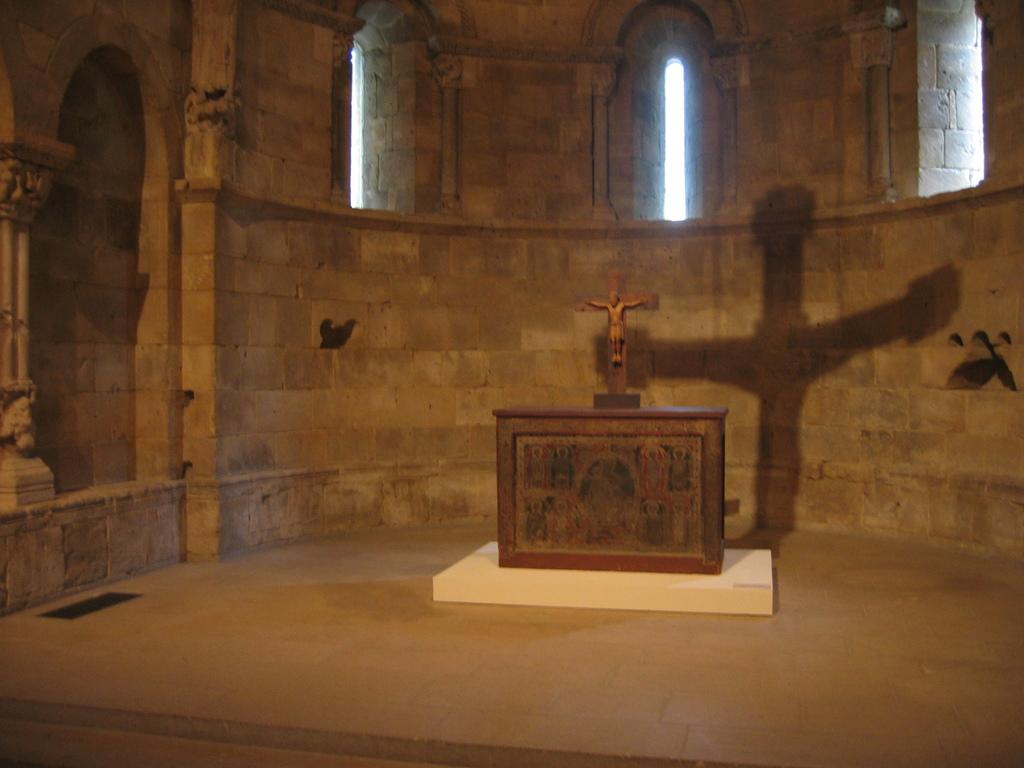What is the main subject in the image? There is a statue in the image. What can be seen in the background of the image? There is a brick wall in the background of the image. Are there any openings in the image? Yes, windows are present in the image. What type of wood is used to construct the arm of the statue in the image? There is no mention of an arm on the statue in the image, and therefore no type of wood can be determined. 